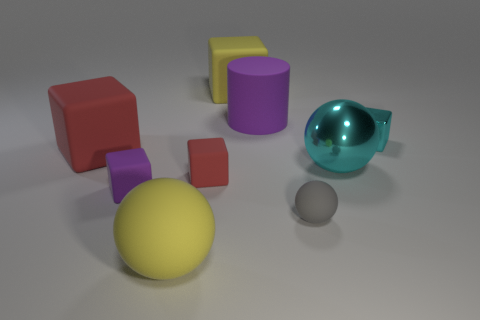Is there a red block that has the same size as the gray rubber object?
Your answer should be very brief. Yes. The small matte object that is the same color as the rubber cylinder is what shape?
Keep it short and to the point. Cube. How many other metallic cubes have the same size as the metallic block?
Give a very brief answer. 0. There is a purple matte thing behind the big red object; does it have the same size as the matte ball that is on the left side of the large yellow rubber block?
Offer a very short reply. Yes. What number of objects are large matte things or large objects in front of the tiny gray ball?
Keep it short and to the point. 4. The metallic ball has what color?
Your answer should be compact. Cyan. There is a large ball behind the ball that is on the left side of the large matte cube that is to the right of the small purple thing; what is it made of?
Provide a short and direct response. Metal. What size is the gray sphere that is the same material as the yellow sphere?
Provide a succinct answer. Small. Is there a small shiny thing that has the same color as the large metal sphere?
Keep it short and to the point. Yes. There is a purple matte cylinder; is its size the same as the block in front of the small red rubber thing?
Offer a very short reply. No. 